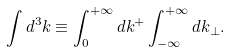<formula> <loc_0><loc_0><loc_500><loc_500>\int d ^ { 3 } { k } \equiv \int _ { 0 } ^ { + \infty } d k ^ { + } \int _ { - \infty } ^ { + \infty } d { k } _ { \perp } .</formula> 